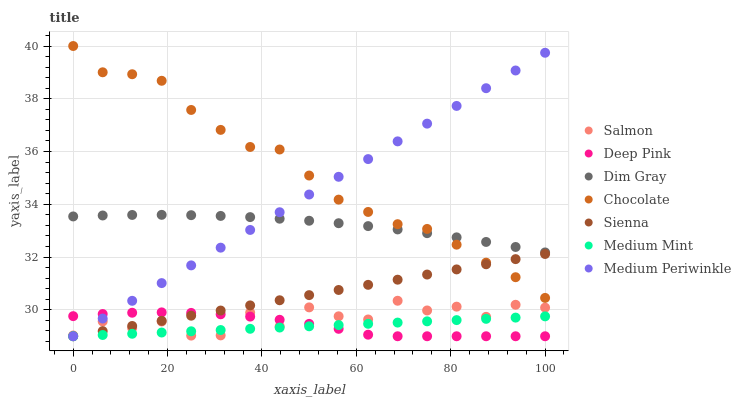Does Medium Mint have the minimum area under the curve?
Answer yes or no. Yes. Does Chocolate have the maximum area under the curve?
Answer yes or no. Yes. Does Dim Gray have the minimum area under the curve?
Answer yes or no. No. Does Dim Gray have the maximum area under the curve?
Answer yes or no. No. Is Medium Mint the smoothest?
Answer yes or no. Yes. Is Salmon the roughest?
Answer yes or no. Yes. Is Dim Gray the smoothest?
Answer yes or no. No. Is Dim Gray the roughest?
Answer yes or no. No. Does Medium Mint have the lowest value?
Answer yes or no. Yes. Does Dim Gray have the lowest value?
Answer yes or no. No. Does Chocolate have the highest value?
Answer yes or no. Yes. Does Dim Gray have the highest value?
Answer yes or no. No. Is Salmon less than Dim Gray?
Answer yes or no. Yes. Is Chocolate greater than Medium Mint?
Answer yes or no. Yes. Does Medium Periwinkle intersect Salmon?
Answer yes or no. Yes. Is Medium Periwinkle less than Salmon?
Answer yes or no. No. Is Medium Periwinkle greater than Salmon?
Answer yes or no. No. Does Salmon intersect Dim Gray?
Answer yes or no. No. 